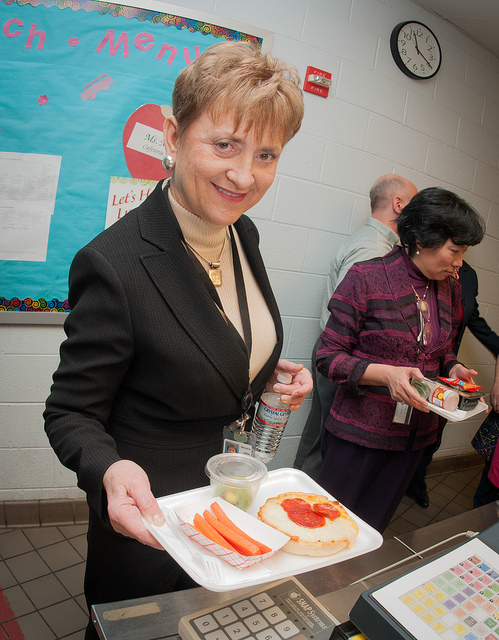Extract all visible text content from this image. ch Menu 6 5 3 0 2 1 4 8 6 9 8 7 2 1 7 8 9 10 11 12 Let s 